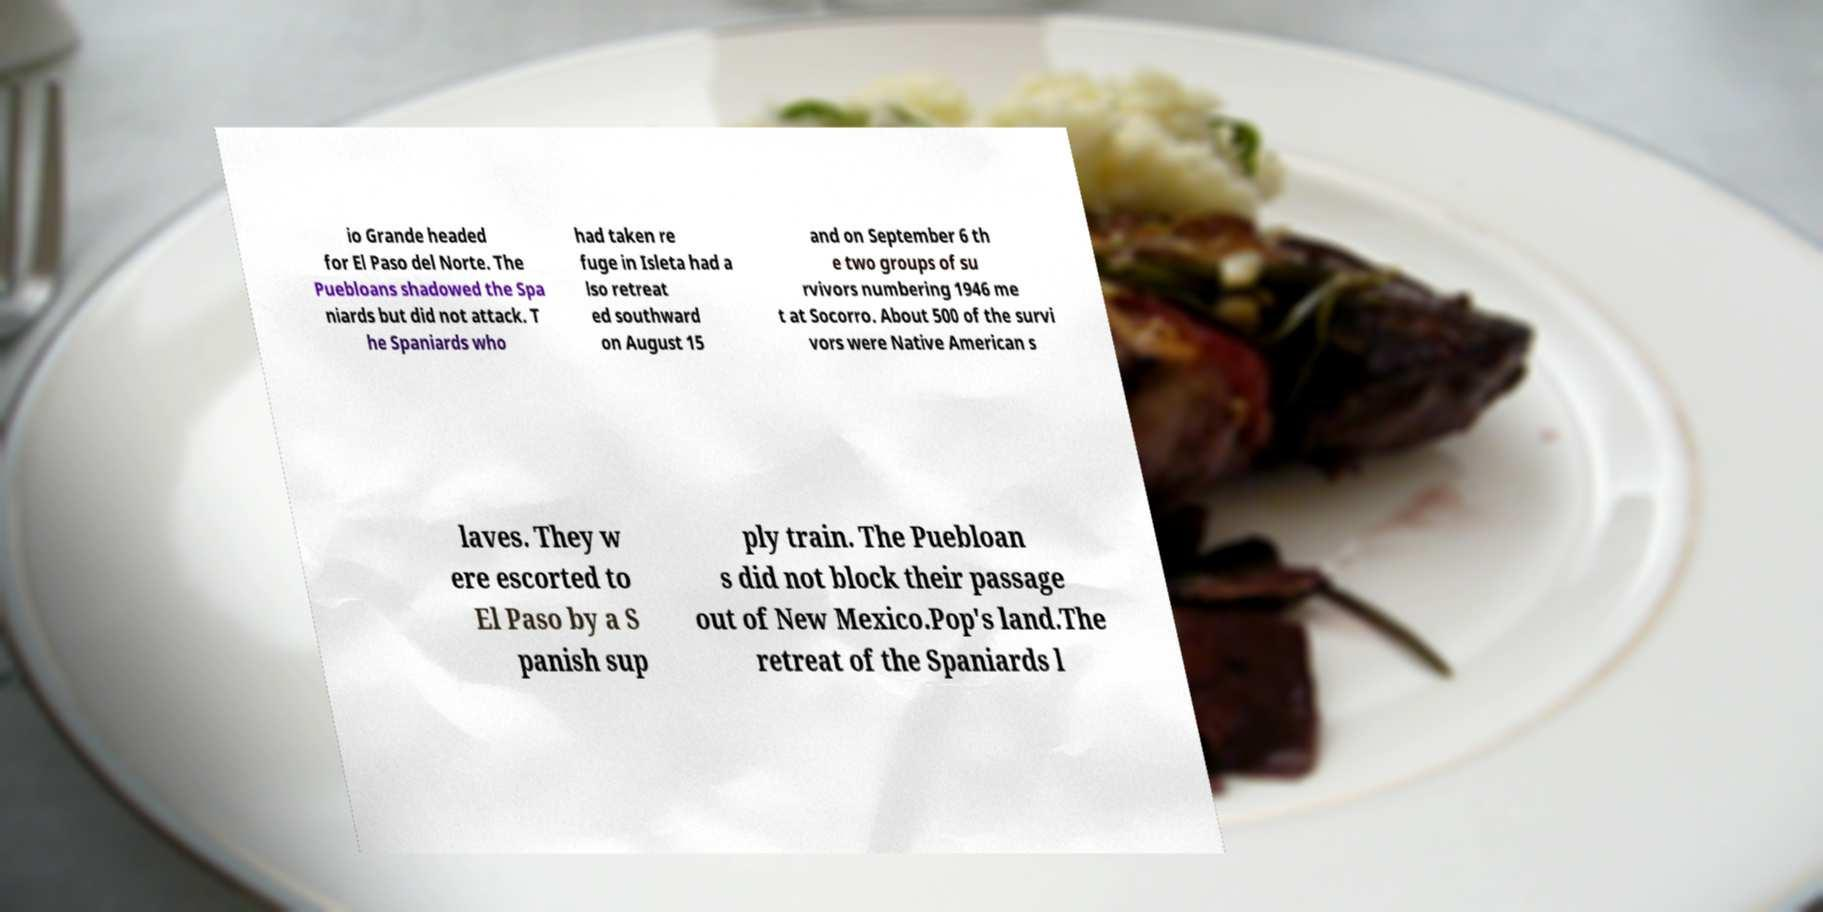Can you read and provide the text displayed in the image?This photo seems to have some interesting text. Can you extract and type it out for me? io Grande headed for El Paso del Norte. The Puebloans shadowed the Spa niards but did not attack. T he Spaniards who had taken re fuge in Isleta had a lso retreat ed southward on August 15 and on September 6 th e two groups of su rvivors numbering 1946 me t at Socorro. About 500 of the survi vors were Native American s laves. They w ere escorted to El Paso by a S panish sup ply train. The Puebloan s did not block their passage out of New Mexico.Pop's land.The retreat of the Spaniards l 